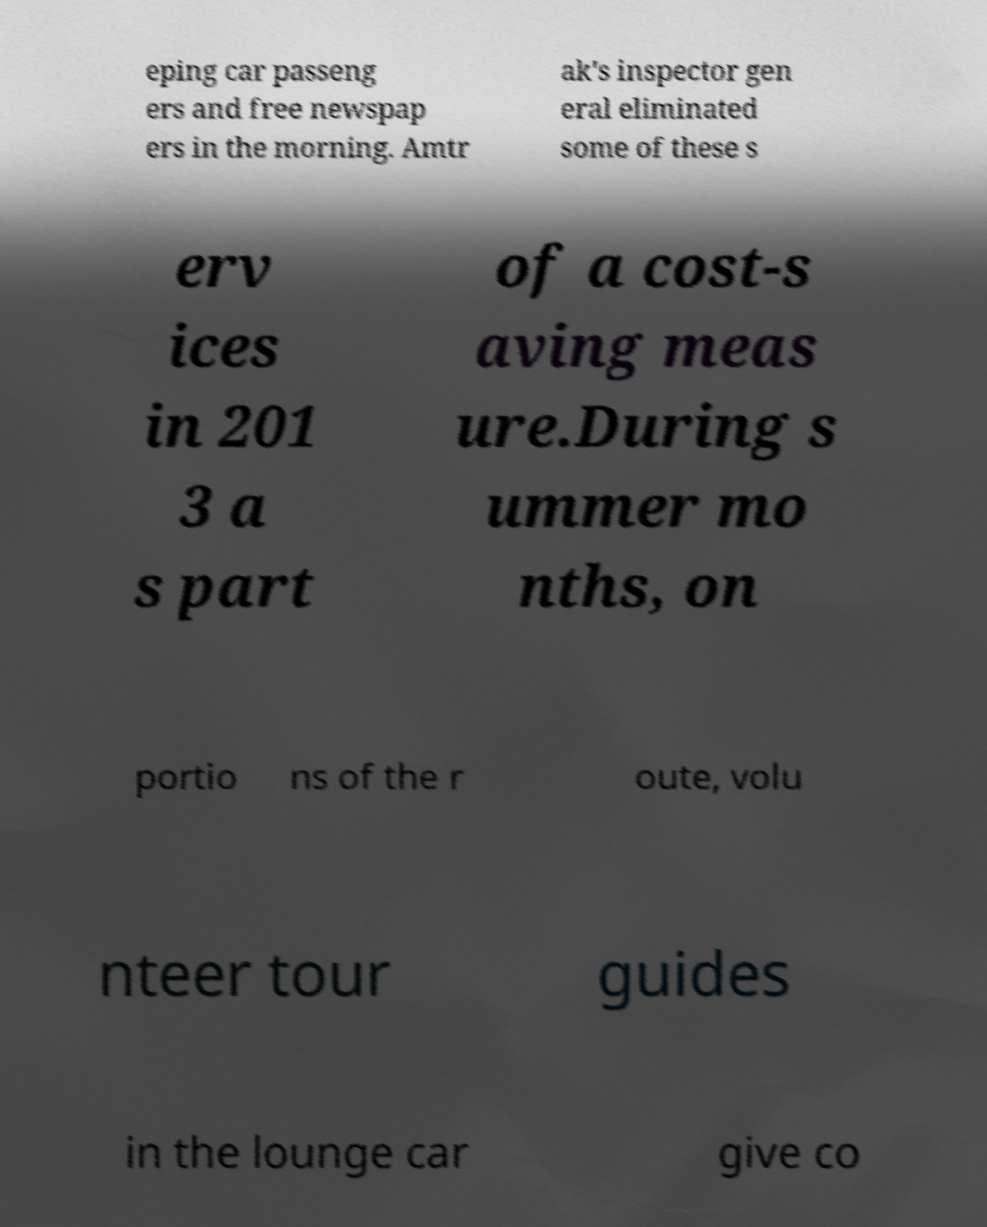Please read and relay the text visible in this image. What does it say? eping car passeng ers and free newspap ers in the morning. Amtr ak's inspector gen eral eliminated some of these s erv ices in 201 3 a s part of a cost-s aving meas ure.During s ummer mo nths, on portio ns of the r oute, volu nteer tour guides in the lounge car give co 